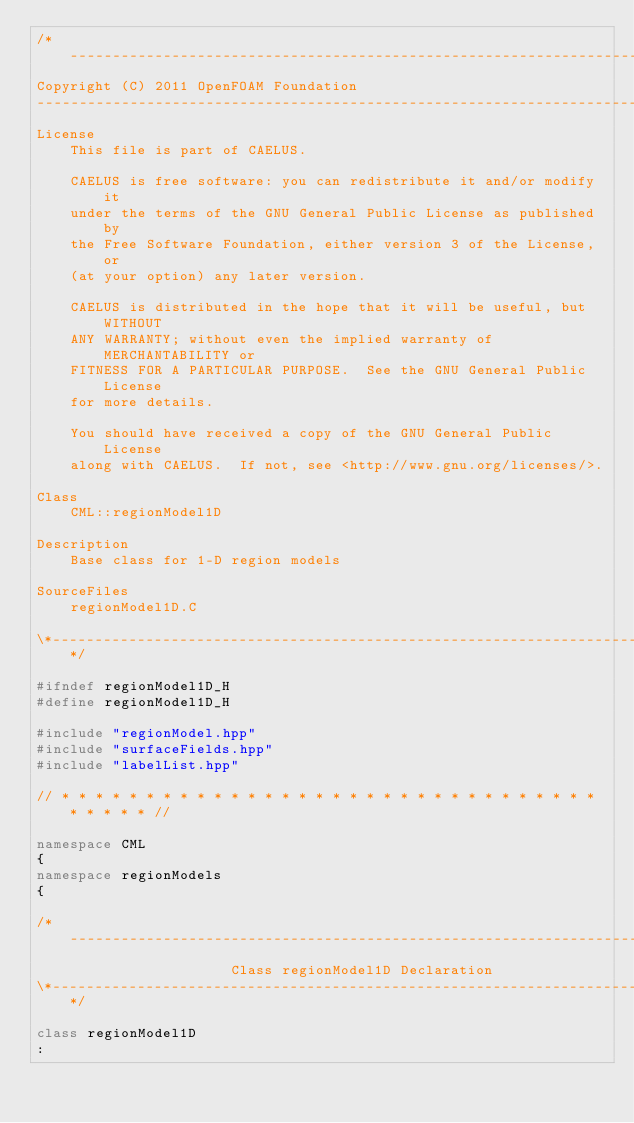Convert code to text. <code><loc_0><loc_0><loc_500><loc_500><_C++_>/*---------------------------------------------------------------------------*\
Copyright (C) 2011 OpenFOAM Foundation
-------------------------------------------------------------------------------
License
    This file is part of CAELUS.

    CAELUS is free software: you can redistribute it and/or modify it
    under the terms of the GNU General Public License as published by
    the Free Software Foundation, either version 3 of the License, or
    (at your option) any later version.

    CAELUS is distributed in the hope that it will be useful, but WITHOUT
    ANY WARRANTY; without even the implied warranty of MERCHANTABILITY or
    FITNESS FOR A PARTICULAR PURPOSE.  See the GNU General Public License
    for more details.

    You should have received a copy of the GNU General Public License
    along with CAELUS.  If not, see <http://www.gnu.org/licenses/>.

Class
    CML::regionModel1D

Description
    Base class for 1-D region models

SourceFiles
    regionModel1D.C

\*---------------------------------------------------------------------------*/

#ifndef regionModel1D_H
#define regionModel1D_H

#include "regionModel.hpp"
#include "surfaceFields.hpp"
#include "labelList.hpp"

// * * * * * * * * * * * * * * * * * * * * * * * * * * * * * * * * * * * * * //

namespace CML
{
namespace regionModels
{

/*---------------------------------------------------------------------------*\
                       Class regionModel1D Declaration
\*---------------------------------------------------------------------------*/

class regionModel1D
:</code> 